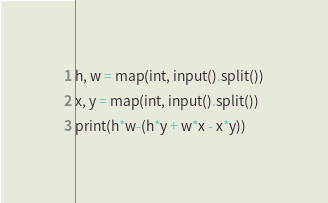Convert code to text. <code><loc_0><loc_0><loc_500><loc_500><_Python_>h, w = map(int, input().split())
x, y = map(int, input().split())
print(h*w-(h*y + w*x - x*y))</code> 